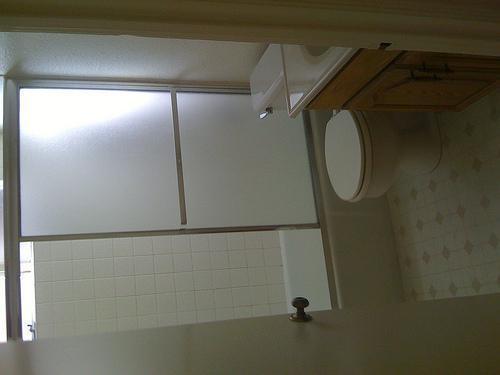How many toilets are in the photo?
Give a very brief answer. 1. 